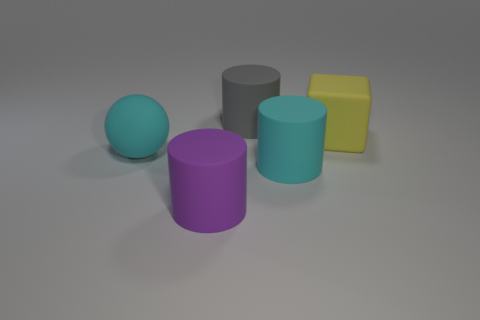How many big cyan matte things are behind the object that is left of the purple matte object?
Provide a succinct answer. 0. What number of matte objects are large purple cylinders or balls?
Your answer should be compact. 2. Is there a large purple cylinder that has the same material as the gray cylinder?
Make the answer very short. Yes. What number of objects are either large matte things behind the purple matte thing or rubber cylinders to the right of the purple thing?
Your answer should be very brief. 4. Do the large cylinder left of the gray rubber cylinder and the large rubber cube have the same color?
Keep it short and to the point. No. What number of other objects are there of the same color as the big rubber cube?
Give a very brief answer. 0. There is a cyan thing that is left of the gray thing; is it the same size as the gray cylinder?
Your answer should be very brief. Yes. Is the number of yellow rubber blocks in front of the big cyan sphere the same as the number of things that are in front of the gray rubber thing?
Your response must be concise. No. Is there anything else that has the same shape as the large purple matte thing?
Offer a very short reply. Yes. Are there the same number of large matte balls in front of the ball and tiny purple things?
Ensure brevity in your answer.  Yes. 